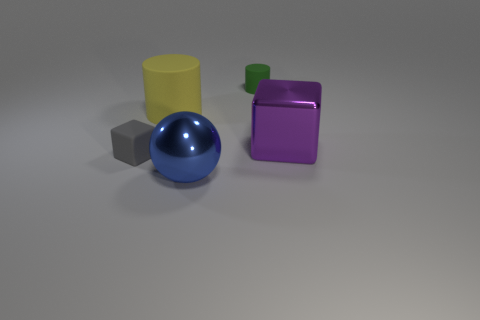Are there the same number of large yellow rubber objects in front of the purple shiny block and green cylinders?
Give a very brief answer. No. What color is the cube that is the same size as the yellow rubber cylinder?
Provide a short and direct response. Purple. Are there any small purple rubber things that have the same shape as the big purple metal object?
Your answer should be very brief. No. What material is the cube that is to the right of the large matte object that is right of the block left of the large purple metallic object?
Provide a short and direct response. Metal. How many other things are the same size as the purple block?
Offer a terse response. 2. The large rubber cylinder is what color?
Ensure brevity in your answer.  Yellow. How many rubber things are green balls or small gray objects?
Offer a very short reply. 1. There is a rubber thing that is to the left of the matte cylinder that is to the left of the small rubber thing behind the tiny gray matte object; what size is it?
Provide a succinct answer. Small. There is a thing that is right of the gray object and in front of the big purple metal object; how big is it?
Make the answer very short. Large. Is the color of the cube on the left side of the big purple thing the same as the matte cylinder that is right of the yellow matte object?
Your answer should be compact. No. 